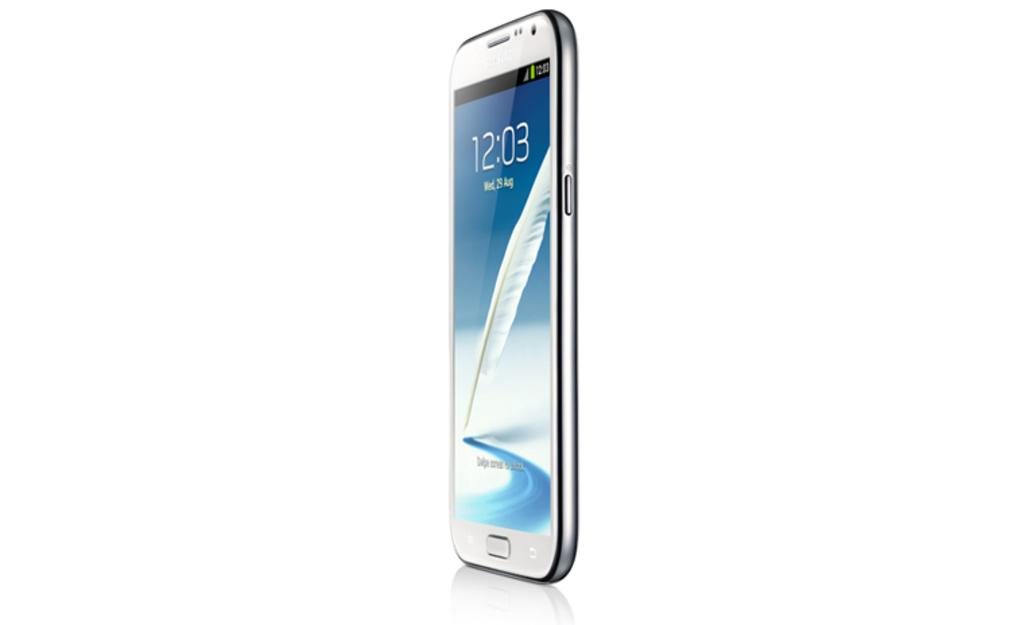<image>
Write a terse but informative summary of the picture. A cell phone standing up on it's end with the time 12:03 on it. 